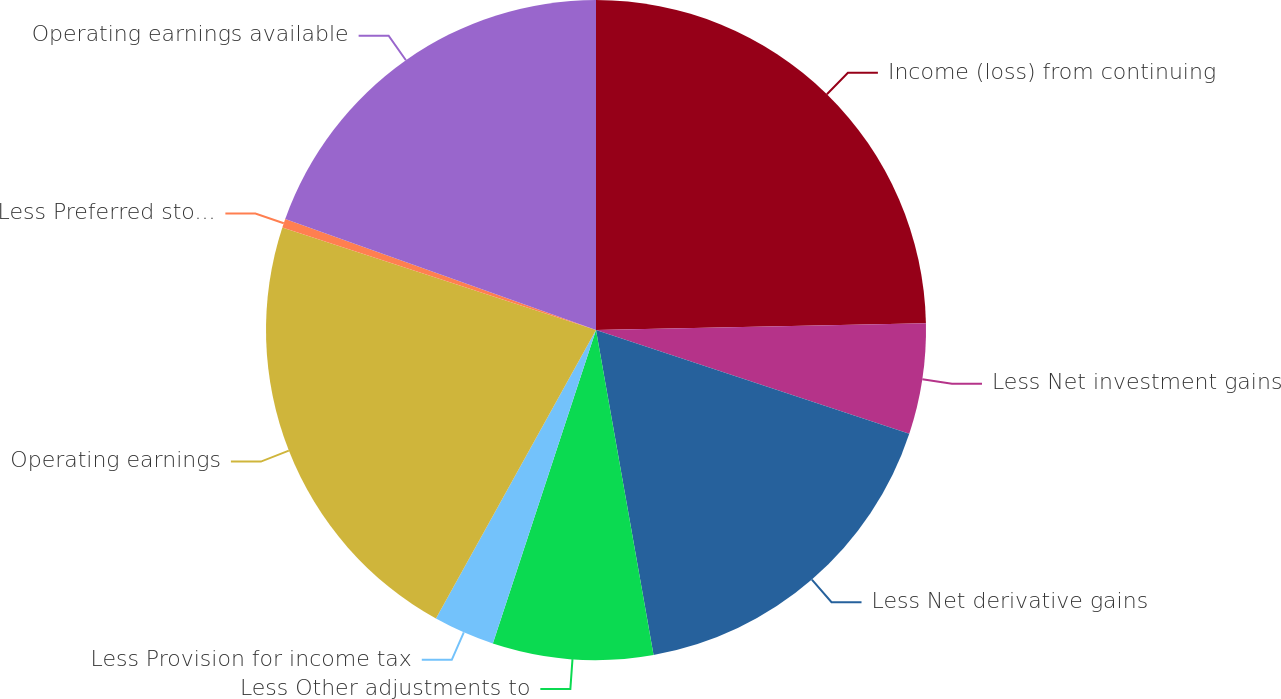Convert chart. <chart><loc_0><loc_0><loc_500><loc_500><pie_chart><fcel>Income (loss) from continuing<fcel>Less Net investment gains<fcel>Less Net derivative gains<fcel>Less Other adjustments to<fcel>Less Provision for income tax<fcel>Operating earnings<fcel>Less Preferred stock dividends<fcel>Operating earnings available<nl><fcel>24.67%<fcel>5.42%<fcel>17.12%<fcel>7.85%<fcel>3.0%<fcel>21.97%<fcel>0.43%<fcel>19.54%<nl></chart> 